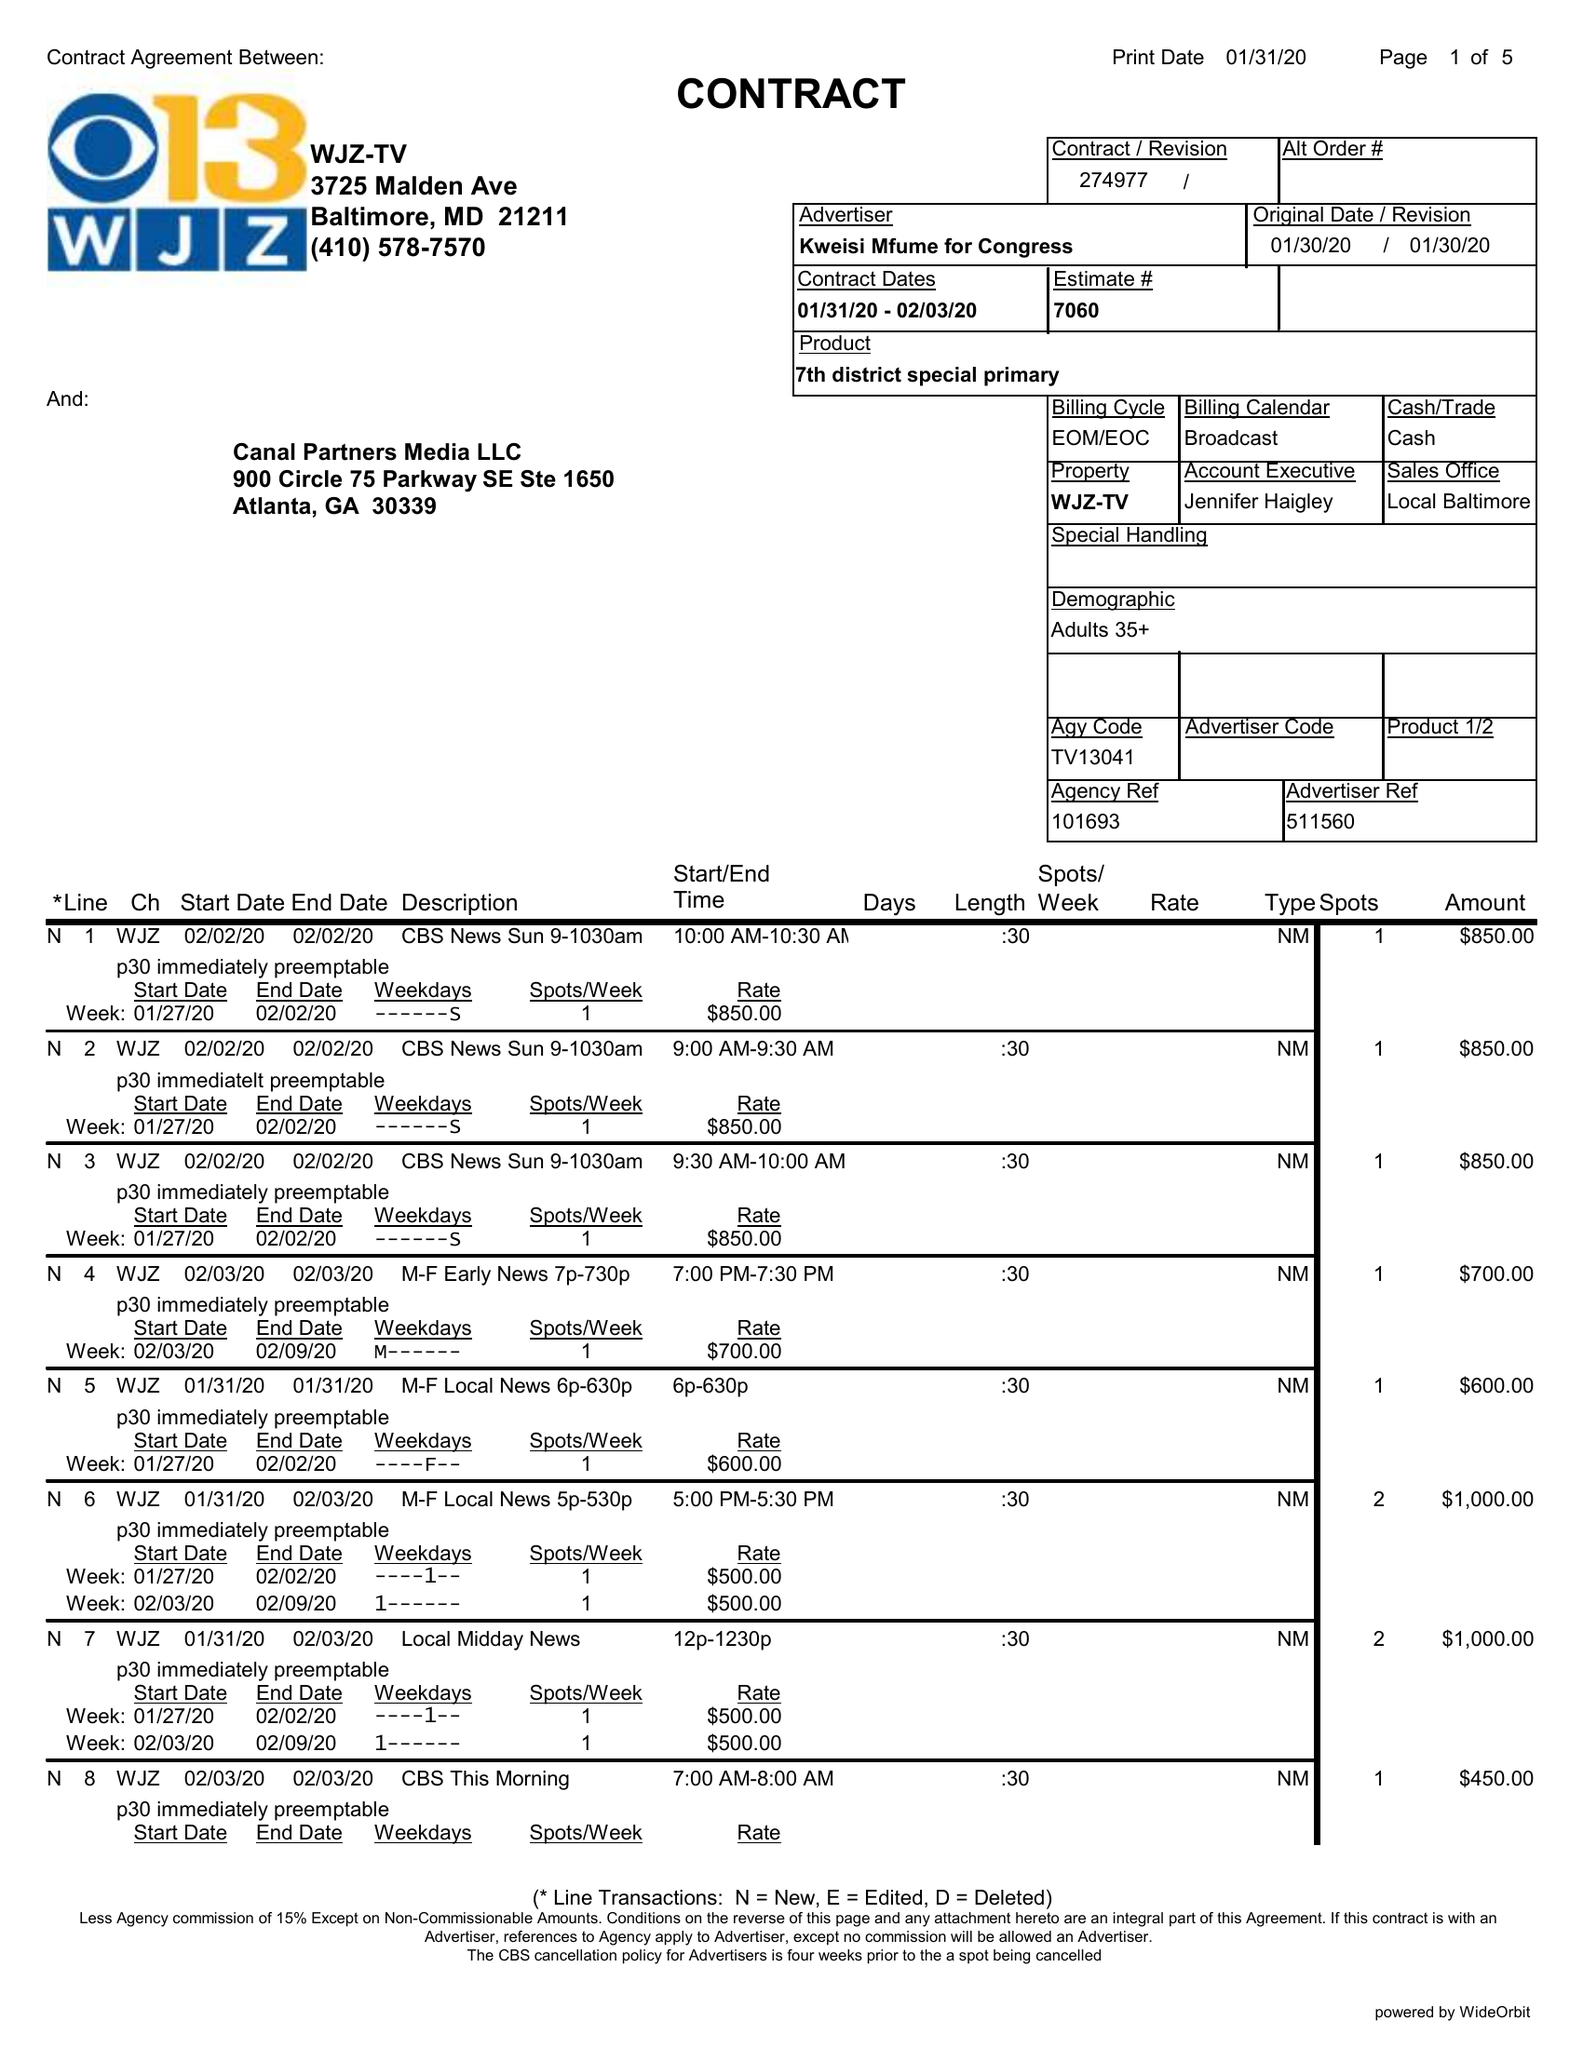What is the value for the flight_to?
Answer the question using a single word or phrase. 02/03/20 